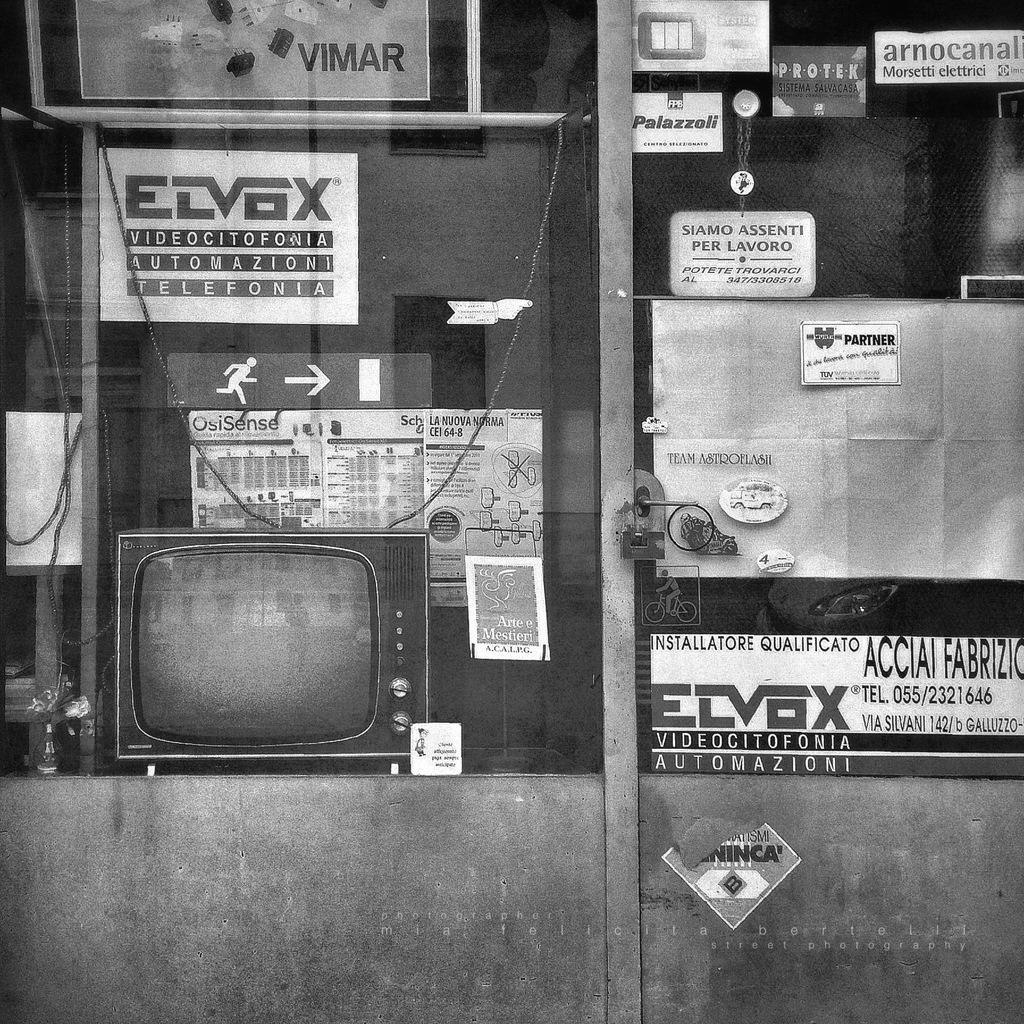<image>
Describe the image concisely. A storefront with a sign that says ECVBX in the window. 